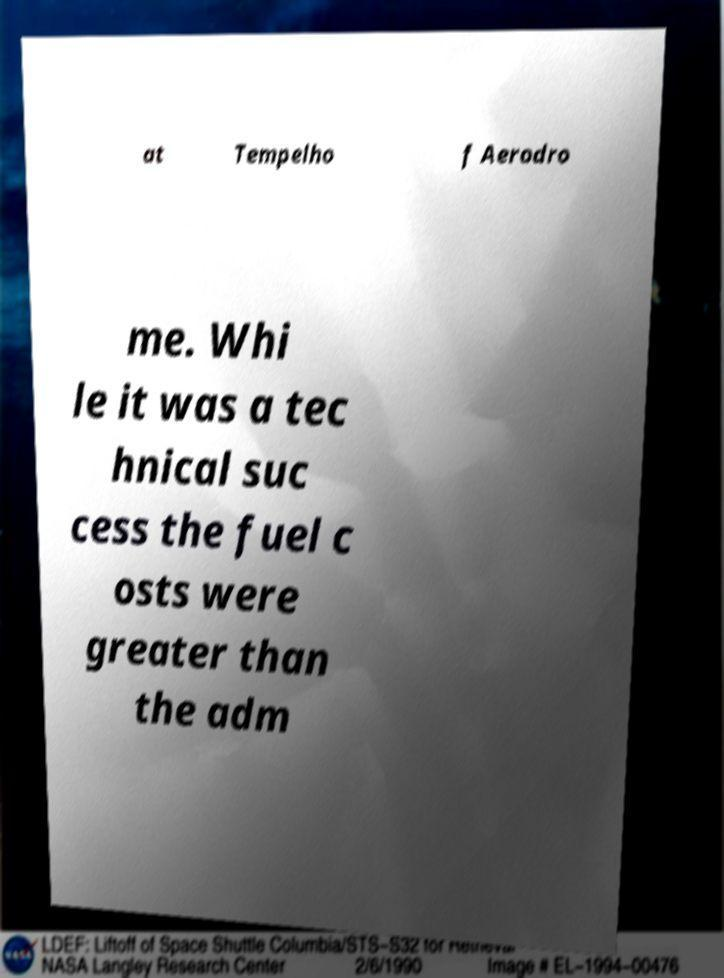There's text embedded in this image that I need extracted. Can you transcribe it verbatim? at Tempelho f Aerodro me. Whi le it was a tec hnical suc cess the fuel c osts were greater than the adm 